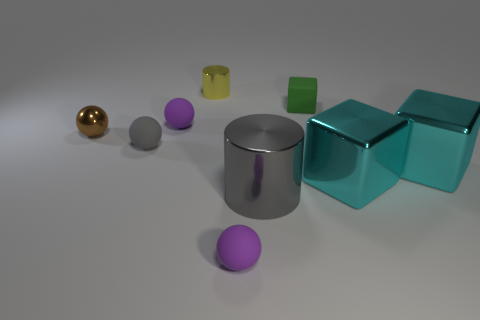Add 1 tiny brown metal things. How many objects exist? 10 Subtract all cylinders. How many objects are left? 7 Add 6 shiny cylinders. How many shiny cylinders are left? 8 Add 4 big cyan metallic things. How many big cyan metallic things exist? 6 Subtract 0 cyan spheres. How many objects are left? 9 Subtract all tiny matte balls. Subtract all gray metallic cylinders. How many objects are left? 5 